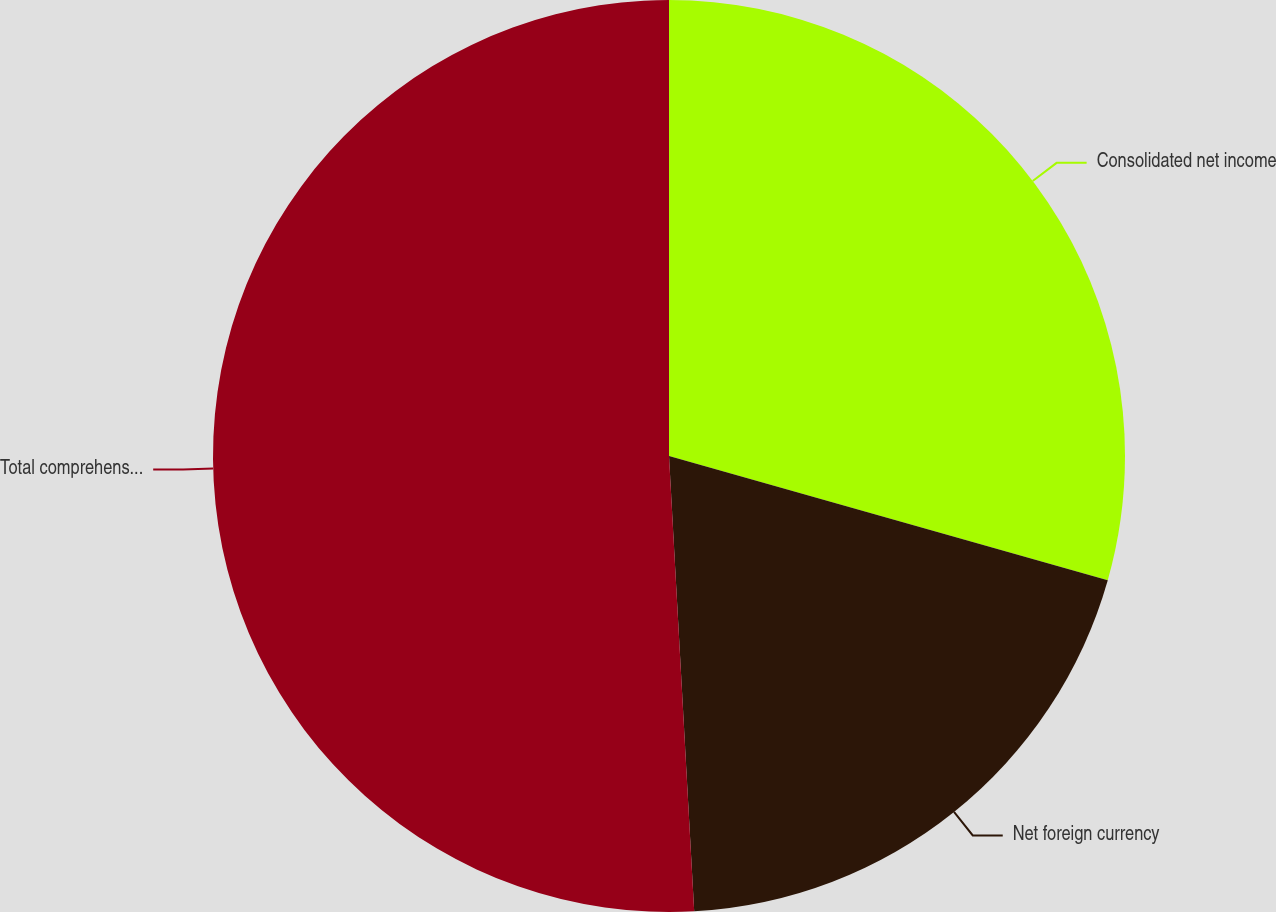<chart> <loc_0><loc_0><loc_500><loc_500><pie_chart><fcel>Consolidated net income<fcel>Net foreign currency<fcel>Total comprehensive income<nl><fcel>29.39%<fcel>19.73%<fcel>50.88%<nl></chart> 